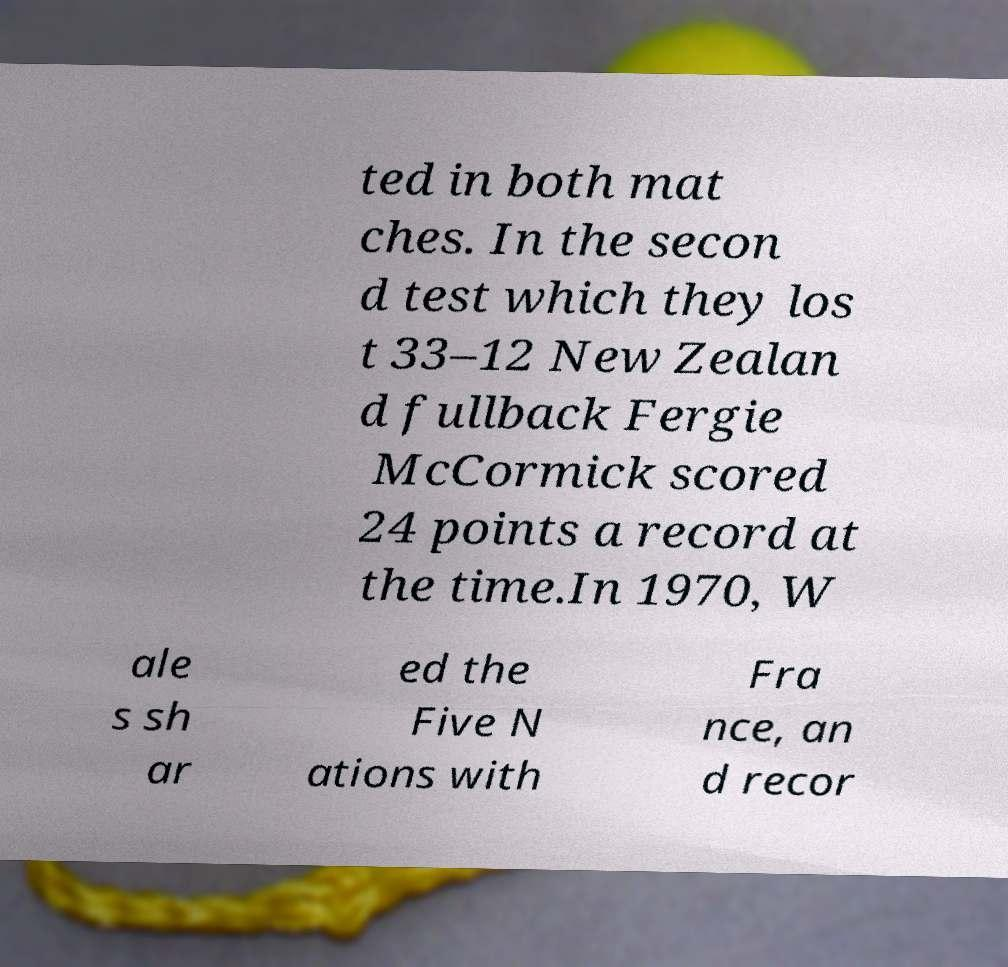Please read and relay the text visible in this image. What does it say? ted in both mat ches. In the secon d test which they los t 33–12 New Zealan d fullback Fergie McCormick scored 24 points a record at the time.In 1970, W ale s sh ar ed the Five N ations with Fra nce, an d recor 